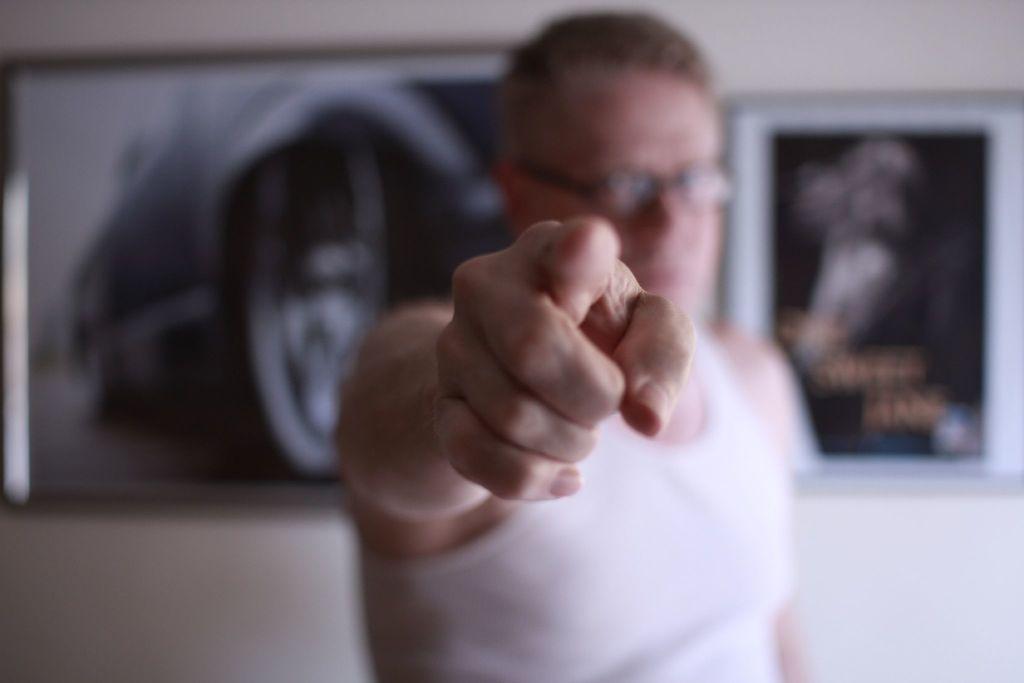In one or two sentences, can you explain what this image depicts? In the center of this picture there is a person seems to be standing. In the background we can see the picture frames hanging on the wall and the background of the image is blurry. 